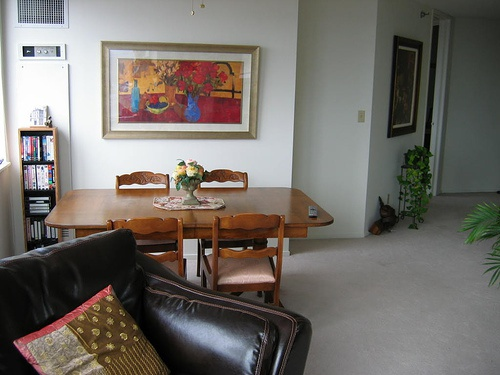Describe the objects in this image and their specific colors. I can see couch in gray, black, maroon, and olive tones, dining table in gray, maroon, and darkgray tones, chair in gray, maroon, and black tones, chair in gray, maroon, black, and brown tones, and potted plant in gray, black, and darkgreen tones in this image. 